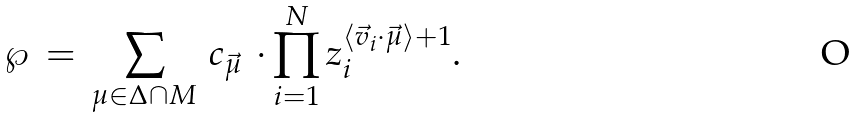Convert formula to latex. <formula><loc_0><loc_0><loc_500><loc_500>\wp \, = \, \sum _ { \mu \in { \Delta \cap M } } \, c _ { \vec { \mu } } \, \cdot \prod _ { i = 1 } ^ { N } z _ { i } ^ { \langle \vec { v } _ { i } \cdot \vec { \mu } \rangle + 1 } .</formula> 